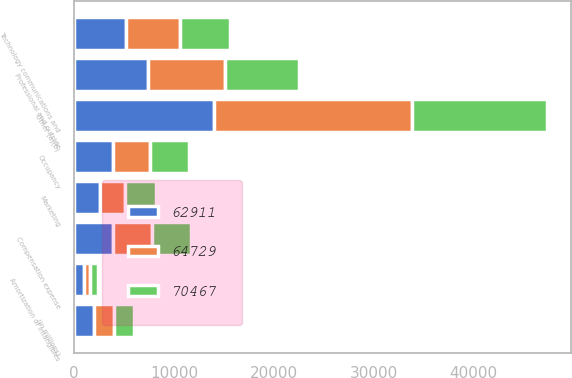<chart> <loc_0><loc_0><loc_500><loc_500><stacked_bar_chart><ecel><fcel>(in millions)<fcel>Compensation expense<fcel>Occupancy<fcel>Technology communications and<fcel>Professional and outside<fcel>Marketing<fcel>Other (a)(b)<fcel>Amortization of intangibles<nl><fcel>64729<fcel>2013<fcel>3895<fcel>3693<fcel>5425<fcel>7641<fcel>2500<fcel>19761<fcel>637<nl><fcel>62911<fcel>2012<fcel>3895<fcel>3925<fcel>5224<fcel>7429<fcel>2577<fcel>14032<fcel>957<nl><fcel>70467<fcel>2011<fcel>3895<fcel>3895<fcel>4947<fcel>7482<fcel>3143<fcel>13559<fcel>848<nl></chart> 